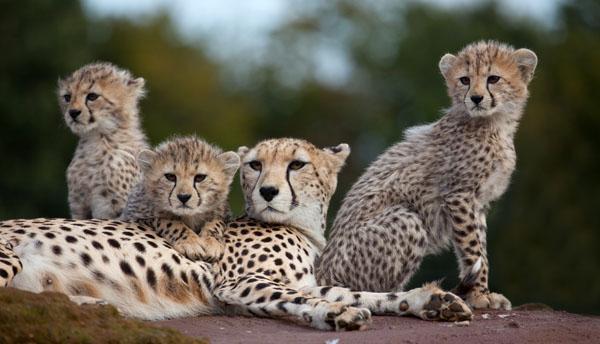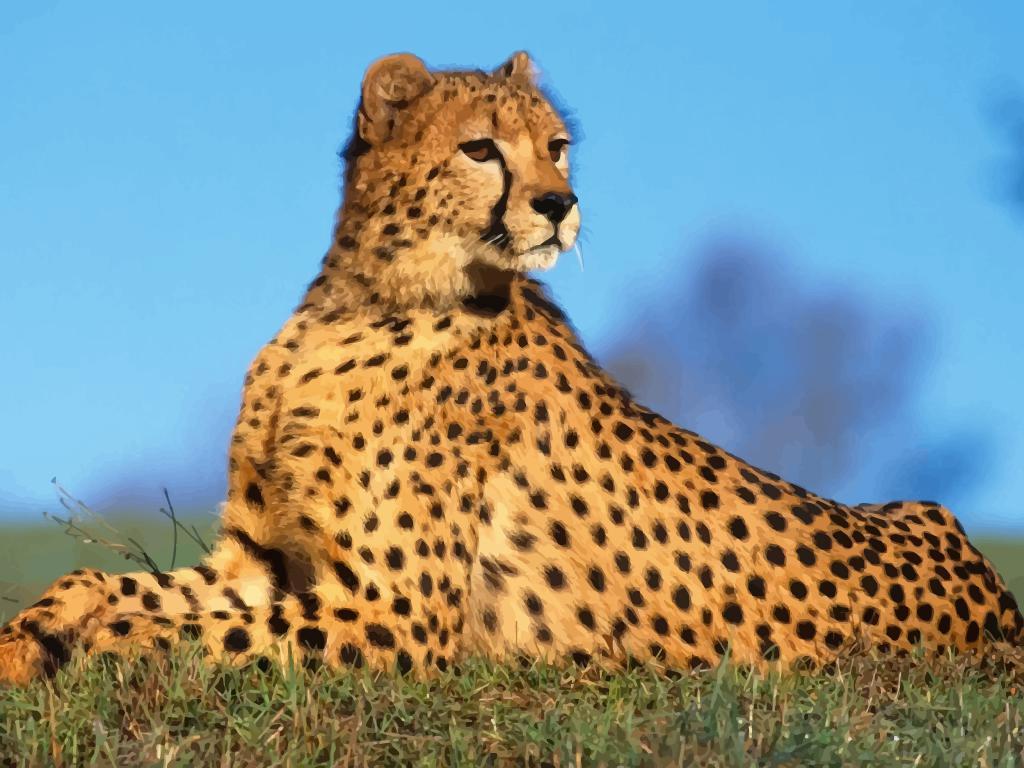The first image is the image on the left, the second image is the image on the right. Considering the images on both sides, is "One cheetah's front paws are off the ground." valid? Answer yes or no. No. The first image is the image on the left, the second image is the image on the right. Analyze the images presented: Is the assertion "One image contains one cheetah, with its neck turned to gaze rightward, and the other image shows one cheetah in profile in a rightward bounding pose, with at least its front paws off the ground." valid? Answer yes or no. No. 